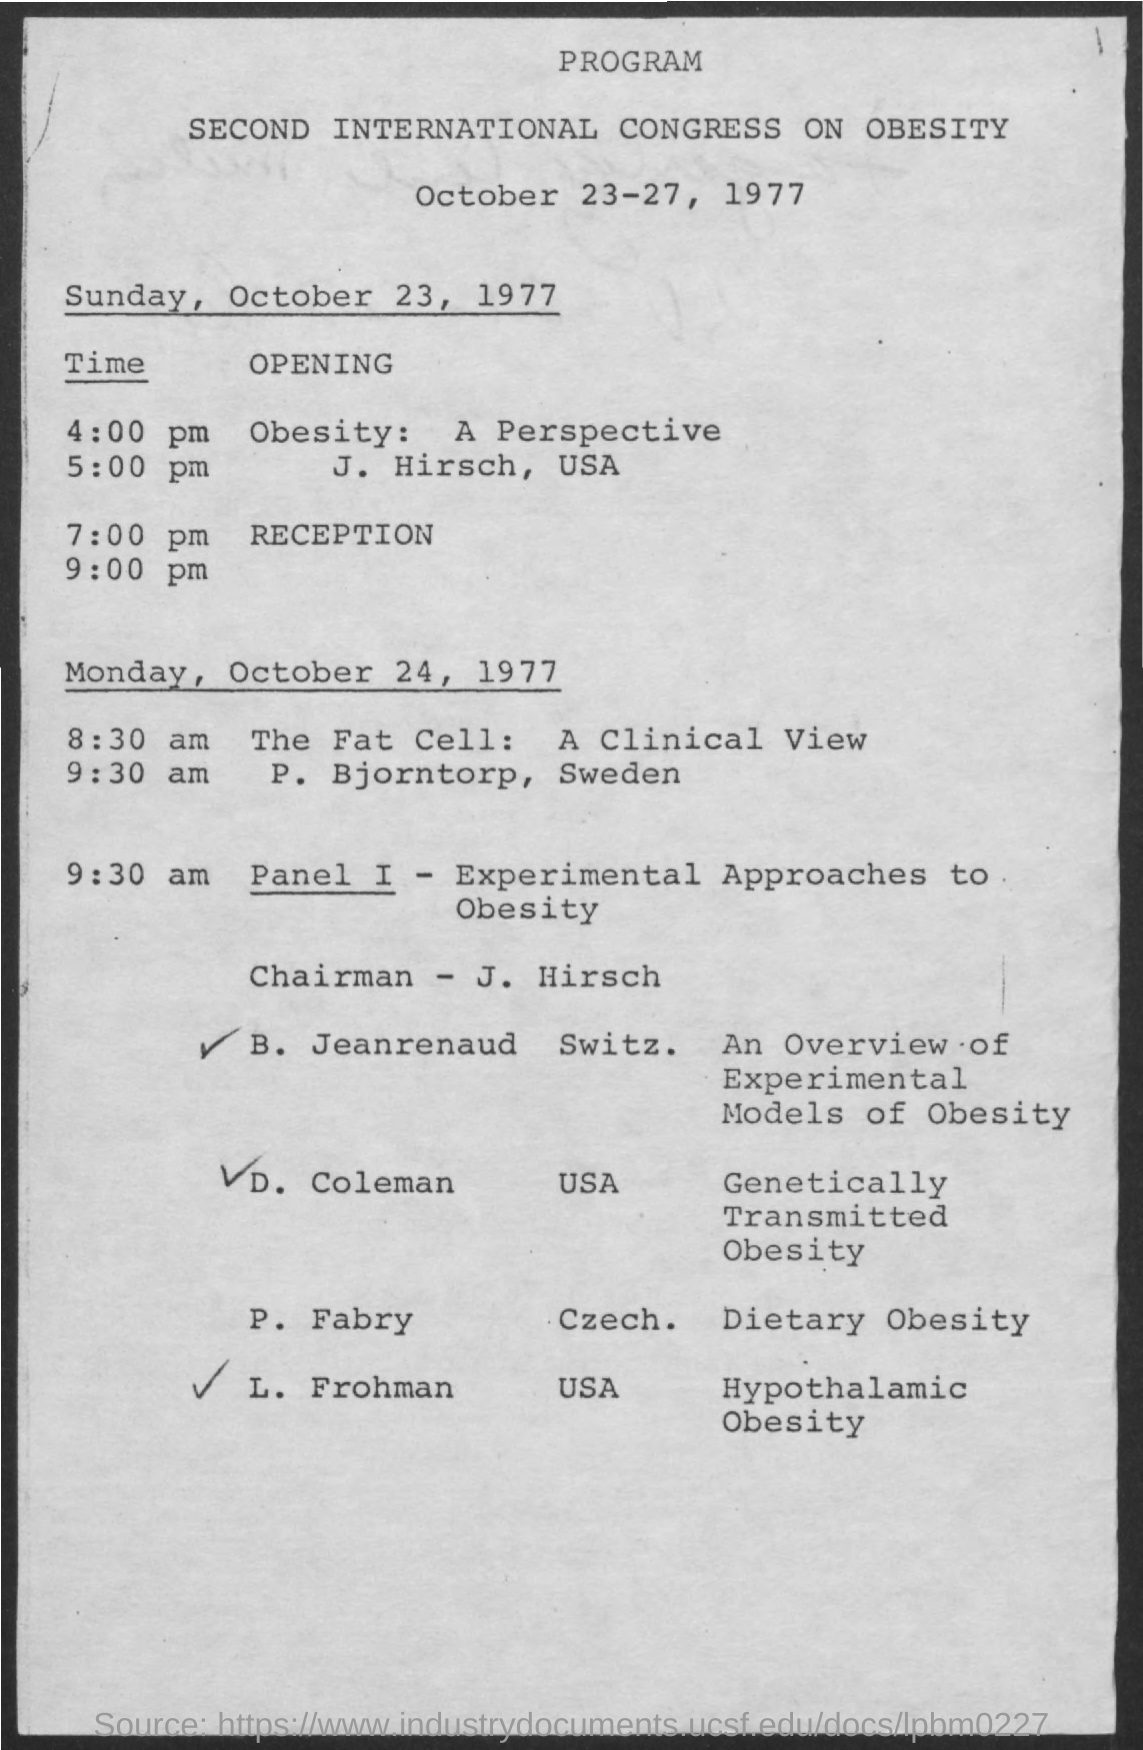What topics are covered in this congress? The congress covers a range of topics including clinical views on fat cells, experimental approaches to obesity, and specific aspects such as genetically transmitted obesity and dietary obesity. 